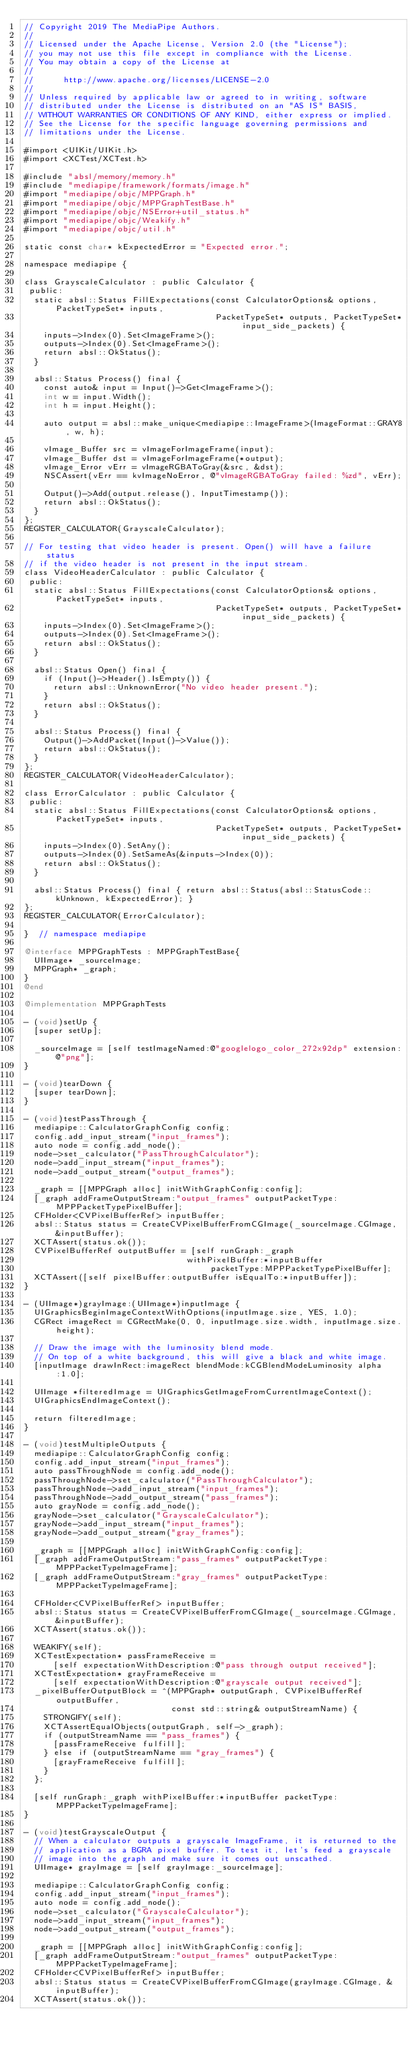Convert code to text. <code><loc_0><loc_0><loc_500><loc_500><_ObjectiveC_>// Copyright 2019 The MediaPipe Authors.
//
// Licensed under the Apache License, Version 2.0 (the "License");
// you may not use this file except in compliance with the License.
// You may obtain a copy of the License at
//
//      http://www.apache.org/licenses/LICENSE-2.0
//
// Unless required by applicable law or agreed to in writing, software
// distributed under the License is distributed on an "AS IS" BASIS,
// WITHOUT WARRANTIES OR CONDITIONS OF ANY KIND, either express or implied.
// See the License for the specific language governing permissions and
// limitations under the License.

#import <UIKit/UIKit.h>
#import <XCTest/XCTest.h>

#include "absl/memory/memory.h"
#include "mediapipe/framework/formats/image.h"
#import "mediapipe/objc/MPPGraph.h"
#import "mediapipe/objc/MPPGraphTestBase.h"
#import "mediapipe/objc/NSError+util_status.h"
#import "mediapipe/objc/Weakify.h"
#import "mediapipe/objc/util.h"

static const char* kExpectedError = "Expected error.";

namespace mediapipe {

class GrayscaleCalculator : public Calculator {
 public:
  static absl::Status FillExpectations(const CalculatorOptions& options, PacketTypeSet* inputs,
                                       PacketTypeSet* outputs, PacketTypeSet* input_side_packets) {
    inputs->Index(0).Set<ImageFrame>();
    outputs->Index(0).Set<ImageFrame>();
    return absl::OkStatus();
  }

  absl::Status Process() final {
    const auto& input = Input()->Get<ImageFrame>();
    int w = input.Width();
    int h = input.Height();

    auto output = absl::make_unique<mediapipe::ImageFrame>(ImageFormat::GRAY8, w, h);

    vImage_Buffer src = vImageForImageFrame(input);
    vImage_Buffer dst = vImageForImageFrame(*output);
    vImage_Error vErr = vImageRGBAToGray(&src, &dst);
    NSCAssert(vErr == kvImageNoError, @"vImageRGBAToGray failed: %zd", vErr);

    Output()->Add(output.release(), InputTimestamp());
    return absl::OkStatus();
  }
};
REGISTER_CALCULATOR(GrayscaleCalculator);

// For testing that video header is present. Open() will have a failure status
// if the video header is not present in the input stream.
class VideoHeaderCalculator : public Calculator {
 public:
  static absl::Status FillExpectations(const CalculatorOptions& options, PacketTypeSet* inputs,
                                       PacketTypeSet* outputs, PacketTypeSet* input_side_packets) {
    inputs->Index(0).Set<ImageFrame>();
    outputs->Index(0).Set<ImageFrame>();
    return absl::OkStatus();
  }

  absl::Status Open() final {
    if (Input()->Header().IsEmpty()) {
      return absl::UnknownError("No video header present.");
    }
    return absl::OkStatus();
  }

  absl::Status Process() final {
    Output()->AddPacket(Input()->Value());
    return absl::OkStatus();
  }
};
REGISTER_CALCULATOR(VideoHeaderCalculator);

class ErrorCalculator : public Calculator {
 public:
  static absl::Status FillExpectations(const CalculatorOptions& options, PacketTypeSet* inputs,
                                       PacketTypeSet* outputs, PacketTypeSet* input_side_packets) {
    inputs->Index(0).SetAny();
    outputs->Index(0).SetSameAs(&inputs->Index(0));
    return absl::OkStatus();
  }

  absl::Status Process() final { return absl::Status(absl::StatusCode::kUnknown, kExpectedError); }
};
REGISTER_CALCULATOR(ErrorCalculator);

}  // namespace mediapipe

@interface MPPGraphTests : MPPGraphTestBase{
  UIImage* _sourceImage;
  MPPGraph* _graph;
}
@end

@implementation MPPGraphTests

- (void)setUp {
  [super setUp];

  _sourceImage = [self testImageNamed:@"googlelogo_color_272x92dp" extension:@"png"];
}

- (void)tearDown {
  [super tearDown];
}

- (void)testPassThrough {
  mediapipe::CalculatorGraphConfig config;
  config.add_input_stream("input_frames");
  auto node = config.add_node();
  node->set_calculator("PassThroughCalculator");
  node->add_input_stream("input_frames");
  node->add_output_stream("output_frames");

  _graph = [[MPPGraph alloc] initWithGraphConfig:config];
  [_graph addFrameOutputStream:"output_frames" outputPacketType:MPPPacketTypePixelBuffer];
  CFHolder<CVPixelBufferRef> inputBuffer;
  absl::Status status = CreateCVPixelBufferFromCGImage(_sourceImage.CGImage, &inputBuffer);
  XCTAssert(status.ok());
  CVPixelBufferRef outputBuffer = [self runGraph:_graph
                                 withPixelBuffer:*inputBuffer
                                      packetType:MPPPacketTypePixelBuffer];
  XCTAssert([self pixelBuffer:outputBuffer isEqualTo:*inputBuffer]);
}

- (UIImage*)grayImage:(UIImage*)inputImage {
  UIGraphicsBeginImageContextWithOptions(inputImage.size, YES, 1.0);
  CGRect imageRect = CGRectMake(0, 0, inputImage.size.width, inputImage.size.height);

  // Draw the image with the luminosity blend mode.
  // On top of a white background, this will give a black and white image.
  [inputImage drawInRect:imageRect blendMode:kCGBlendModeLuminosity alpha:1.0];

  UIImage *filteredImage = UIGraphicsGetImageFromCurrentImageContext();
  UIGraphicsEndImageContext();

  return filteredImage;
}

- (void)testMultipleOutputs {
  mediapipe::CalculatorGraphConfig config;
  config.add_input_stream("input_frames");
  auto passThroughNode = config.add_node();
  passThroughNode->set_calculator("PassThroughCalculator");
  passThroughNode->add_input_stream("input_frames");
  passThroughNode->add_output_stream("pass_frames");
  auto grayNode = config.add_node();
  grayNode->set_calculator("GrayscaleCalculator");
  grayNode->add_input_stream("input_frames");
  grayNode->add_output_stream("gray_frames");

  _graph = [[MPPGraph alloc] initWithGraphConfig:config];
  [_graph addFrameOutputStream:"pass_frames" outputPacketType:MPPPacketTypeImageFrame];
  [_graph addFrameOutputStream:"gray_frames" outputPacketType:MPPPacketTypeImageFrame];

  CFHolder<CVPixelBufferRef> inputBuffer;
  absl::Status status = CreateCVPixelBufferFromCGImage(_sourceImage.CGImage, &inputBuffer);
  XCTAssert(status.ok());

  WEAKIFY(self);
  XCTestExpectation* passFrameReceive =
      [self expectationWithDescription:@"pass through output received"];
  XCTestExpectation* grayFrameReceive =
      [self expectationWithDescription:@"grayscale output received"];
  _pixelBufferOutputBlock = ^(MPPGraph* outputGraph, CVPixelBufferRef outputBuffer,
                              const std::string& outputStreamName) {
    STRONGIFY(self);
    XCTAssertEqualObjects(outputGraph, self->_graph);
    if (outputStreamName == "pass_frames") {
      [passFrameReceive fulfill];
    } else if (outputStreamName == "gray_frames") {
      [grayFrameReceive fulfill];
    }
  };

  [self runGraph:_graph withPixelBuffer:*inputBuffer packetType:MPPPacketTypeImageFrame];
}

- (void)testGrayscaleOutput {
  // When a calculator outputs a grayscale ImageFrame, it is returned to the
  // application as a BGRA pixel buffer. To test it, let's feed a grayscale
  // image into the graph and make sure it comes out unscathed.
  UIImage* grayImage = [self grayImage:_sourceImage];

  mediapipe::CalculatorGraphConfig config;
  config.add_input_stream("input_frames");
  auto node = config.add_node();
  node->set_calculator("GrayscaleCalculator");
  node->add_input_stream("input_frames");
  node->add_output_stream("output_frames");

  _graph = [[MPPGraph alloc] initWithGraphConfig:config];
  [_graph addFrameOutputStream:"output_frames" outputPacketType:MPPPacketTypeImageFrame];
  CFHolder<CVPixelBufferRef> inputBuffer;
  absl::Status status = CreateCVPixelBufferFromCGImage(grayImage.CGImage, &inputBuffer);
  XCTAssert(status.ok());</code> 